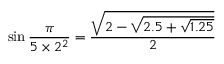<formula> <loc_0><loc_0><loc_500><loc_500>\sin { \frac { \pi } { 5 \times 2 ^ { 2 } } } = { \frac { \sqrt { 2 - { \sqrt { 2 . 5 + { \sqrt { 1 . 2 5 } } } } } } { 2 } }</formula> 